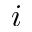Convert formula to latex. <formula><loc_0><loc_0><loc_500><loc_500>i</formula> 